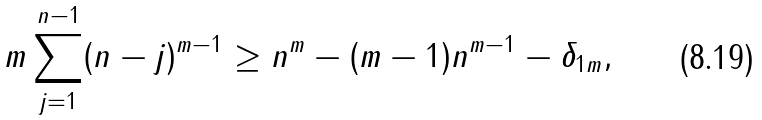<formula> <loc_0><loc_0><loc_500><loc_500>m \sum ^ { n - 1 } _ { j = 1 } ( n - j ) ^ { m - 1 } \geq n ^ { m } - ( m - 1 ) n ^ { m - 1 } - \delta _ { 1 m } ,</formula> 